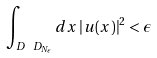Convert formula to latex. <formula><loc_0><loc_0><loc_500><loc_500>\int _ { D \ D _ { N _ { \epsilon } } } d x \left | u ( x ) \right | ^ { 2 } < \epsilon</formula> 